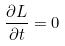<formula> <loc_0><loc_0><loc_500><loc_500>\frac { \partial L } { \partial t } = 0</formula> 